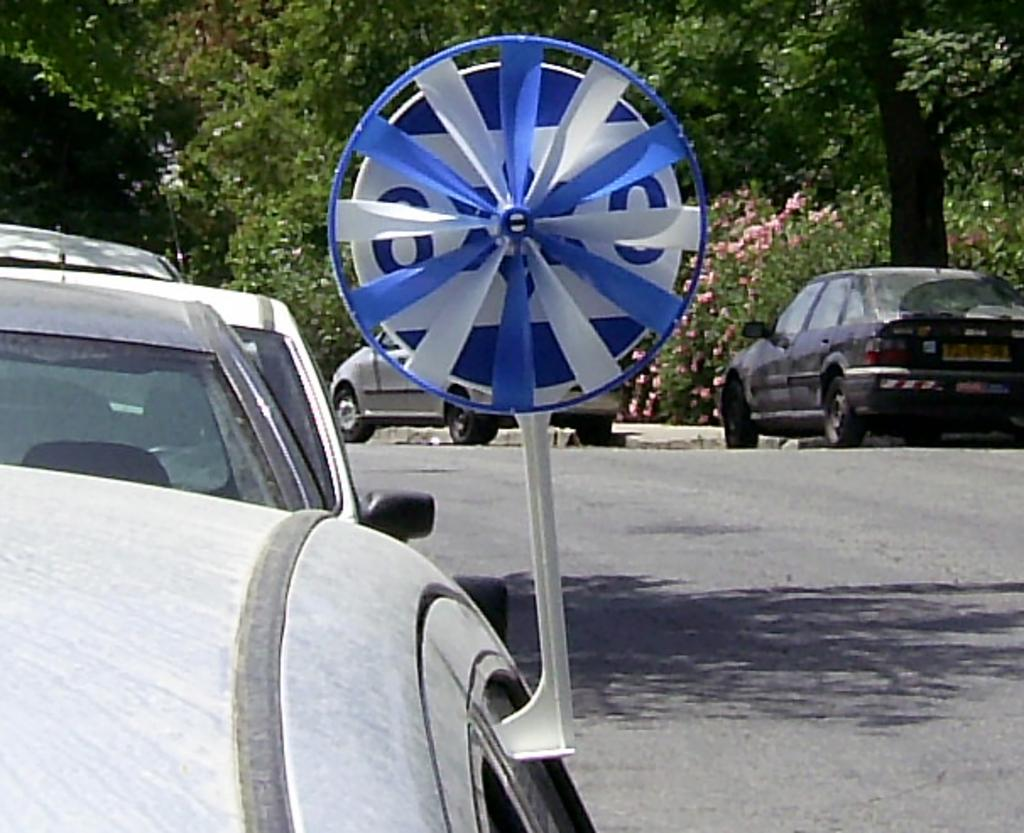What is happening on the road in the image? There are vehicles on the road in the image. Can you describe anything near a car in the image? There is an object near a car in the image. What can be seen in the background of the image? There are trees in the background of the image. What grade does the spoon receive for its performance in the image? There is no spoon present in the image, so it cannot receive a grade. 